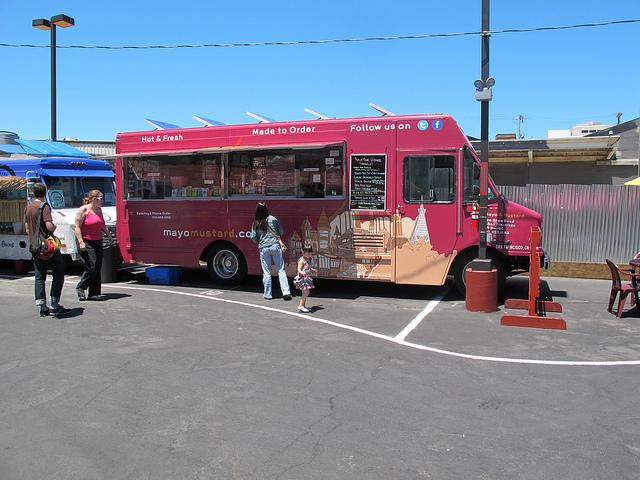On what social networks can this food truck be found?
Be succinct. Twitter and facebook. What kind of food does the food truck sell?
Write a very short answer. Hot dogs. Is this truck speeding?
Quick response, please. No. 